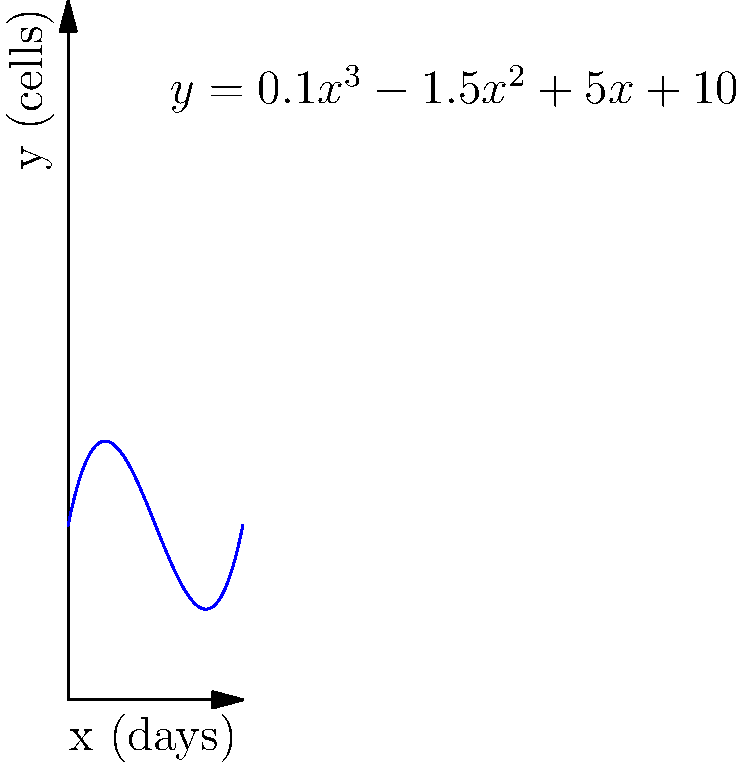As a dermatologist studying skin cell growth, you've modeled the number of cells $y$ in a skin sample over time $x$ (in days) using the cubic function $y = 0.1x^3 - 1.5x^2 + 5x + 10$. At what point does the growth rate of skin cells reach its minimum value? To find the point where the growth rate reaches its minimum:

1) The growth rate is represented by the first derivative of the function:
   $y' = 0.3x^2 - 3x + 5$

2) The minimum growth rate occurs where the second derivative equals zero:
   $y'' = 0.6x - 3 = 0$

3) Solve for x:
   $0.6x = 3$
   $x = 5$

4) To find y at this point, substitute x = 5 into the original function:
   $y = 0.1(5)^3 - 1.5(5)^2 + 5(5) + 10$
   $y = 0.1(125) - 1.5(25) + 25 + 10$
   $y = 12.5 - 37.5 + 25 + 10 = 10$

5) Therefore, the minimum growth rate occurs at the point (5, 10).
Answer: (5, 10) 